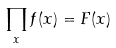Convert formula to latex. <formula><loc_0><loc_0><loc_500><loc_500>\prod _ { x } f ( x ) = F ( x )</formula> 